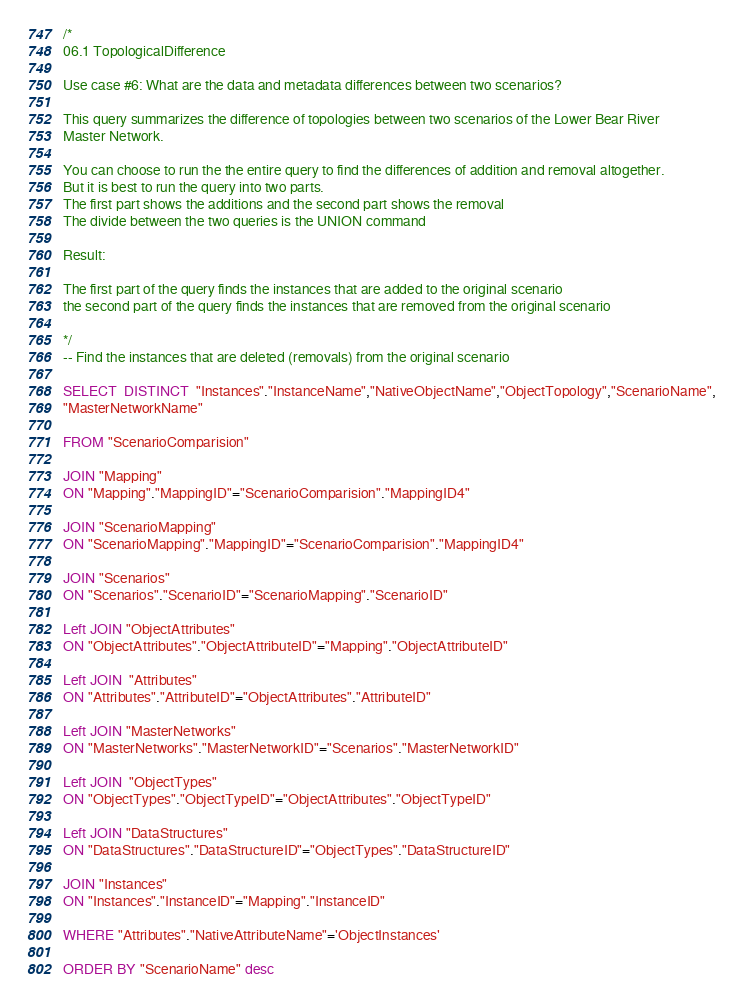Convert code to text. <code><loc_0><loc_0><loc_500><loc_500><_SQL_>/* 
06.1 TopologicalDifference

Use case #6: What are the data and metadata differences between two scenarios?

This query summarizes the difference of topologies between two scenarios of the Lower Bear River 
Master Network. 

You can choose to run the the entire query to find the differences of addition and removal altogether. 
But it is best to run the query into two parts. 
The first part shows the additions and the second part shows the removal
The divide between the two queries is the UNION command 

Result:

The first part of the query finds the instances that are added to the original scenario 
the second part of the query finds the instances that are removed from the original scenario 

*/
-- Find the instances that are deleted (removals) from the original scenario

SELECT  DISTINCT  "Instances"."InstanceName","NativeObjectName","ObjectTopology","ScenarioName",
"MasterNetworkName"

FROM "ScenarioComparision"

JOIN "Mapping"
ON "Mapping"."MappingID"="ScenarioComparision"."MappingID4"

JOIN "ScenarioMapping"
ON "ScenarioMapping"."MappingID"="ScenarioComparision"."MappingID4"

JOIN "Scenarios"
ON "Scenarios"."ScenarioID"="ScenarioMapping"."ScenarioID"

Left JOIN "ObjectAttributes"
ON "ObjectAttributes"."ObjectAttributeID"="Mapping"."ObjectAttributeID"

Left JOIN  "Attributes"
ON "Attributes"."AttributeID"="ObjectAttributes"."AttributeID"

Left JOIN "MasterNetworks" 
ON "MasterNetworks"."MasterNetworkID"="Scenarios"."MasterNetworkID"

Left JOIN  "ObjectTypes"
ON "ObjectTypes"."ObjectTypeID"="ObjectAttributes"."ObjectTypeID"

Left JOIN "DataStructures"
ON "DataStructures"."DataStructureID"="ObjectTypes"."DataStructureID"

JOIN "Instances"
ON "Instances"."InstanceID"="Mapping"."InstanceID"

WHERE "Attributes"."NativeAttributeName"='ObjectInstances'

ORDER BY "ScenarioName" desc 
</code> 